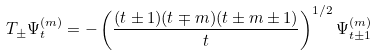Convert formula to latex. <formula><loc_0><loc_0><loc_500><loc_500>T _ { \pm } \Psi ^ { ( m ) } _ { t } = - \left ( \frac { ( t \pm 1 ) ( t \mp m ) ( t \pm m \pm 1 ) } { t } \right ) ^ { 1 / 2 } \Psi ^ { ( m ) } _ { t \pm 1 }</formula> 